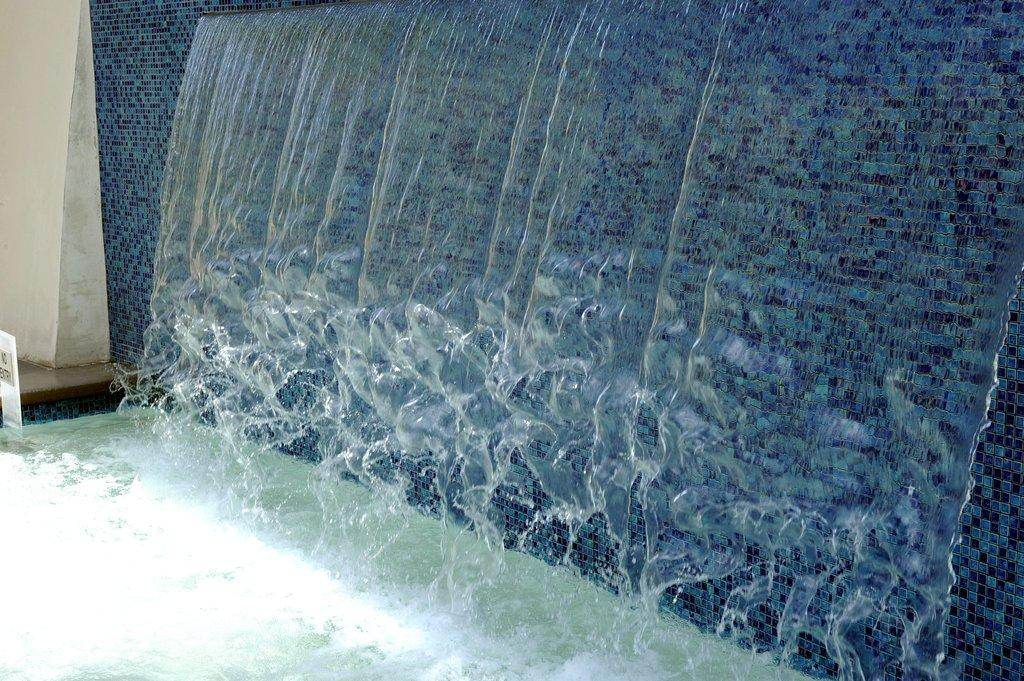What natural feature is present in the image? There is a waterfall in the image. What man-made structure can be seen in the image? There is a wall in the image. What type of sign or message is displayed in the image? There is a board with text in the image. What type of industry is depicted in the image? There is no industry present in the image; it features a waterfall, a wall, and a board with text. Can you see a shelf in the image? There is no shelf present in the image. 